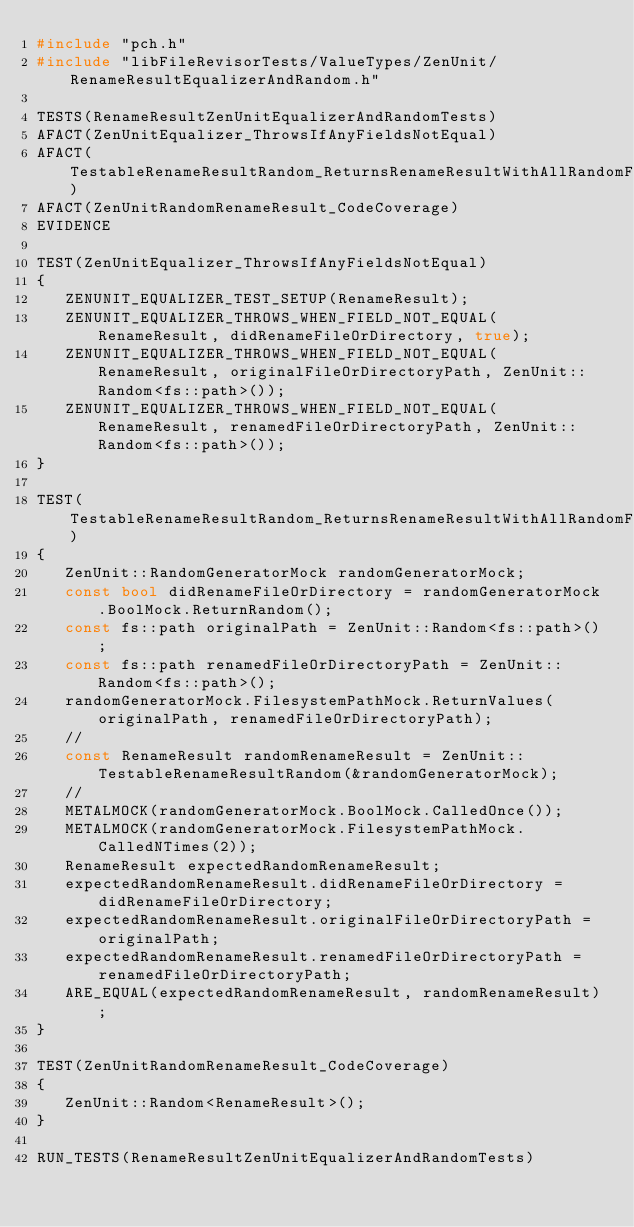<code> <loc_0><loc_0><loc_500><loc_500><_C++_>#include "pch.h"
#include "libFileRevisorTests/ValueTypes/ZenUnit/RenameResultEqualizerAndRandom.h"

TESTS(RenameResultZenUnitEqualizerAndRandomTests)
AFACT(ZenUnitEqualizer_ThrowsIfAnyFieldsNotEqual)
AFACT(TestableRenameResultRandom_ReturnsRenameResultWithAllRandomFields)
AFACT(ZenUnitRandomRenameResult_CodeCoverage)
EVIDENCE

TEST(ZenUnitEqualizer_ThrowsIfAnyFieldsNotEqual)
{
   ZENUNIT_EQUALIZER_TEST_SETUP(RenameResult);
   ZENUNIT_EQUALIZER_THROWS_WHEN_FIELD_NOT_EQUAL(RenameResult, didRenameFileOrDirectory, true);
   ZENUNIT_EQUALIZER_THROWS_WHEN_FIELD_NOT_EQUAL(RenameResult, originalFileOrDirectoryPath, ZenUnit::Random<fs::path>());
   ZENUNIT_EQUALIZER_THROWS_WHEN_FIELD_NOT_EQUAL(RenameResult, renamedFileOrDirectoryPath, ZenUnit::Random<fs::path>());
}

TEST(TestableRenameResultRandom_ReturnsRenameResultWithAllRandomFields)
{
   ZenUnit::RandomGeneratorMock randomGeneratorMock;
   const bool didRenameFileOrDirectory = randomGeneratorMock.BoolMock.ReturnRandom();
   const fs::path originalPath = ZenUnit::Random<fs::path>();
   const fs::path renamedFileOrDirectoryPath = ZenUnit::Random<fs::path>();
   randomGeneratorMock.FilesystemPathMock.ReturnValues(originalPath, renamedFileOrDirectoryPath);
   //
   const RenameResult randomRenameResult = ZenUnit::TestableRenameResultRandom(&randomGeneratorMock);
   //
   METALMOCK(randomGeneratorMock.BoolMock.CalledOnce());
   METALMOCK(randomGeneratorMock.FilesystemPathMock.CalledNTimes(2));
   RenameResult expectedRandomRenameResult;
   expectedRandomRenameResult.didRenameFileOrDirectory = didRenameFileOrDirectory;
   expectedRandomRenameResult.originalFileOrDirectoryPath = originalPath;
   expectedRandomRenameResult.renamedFileOrDirectoryPath = renamedFileOrDirectoryPath;
   ARE_EQUAL(expectedRandomRenameResult, randomRenameResult);
}

TEST(ZenUnitRandomRenameResult_CodeCoverage)
{
   ZenUnit::Random<RenameResult>();
}

RUN_TESTS(RenameResultZenUnitEqualizerAndRandomTests)
</code> 